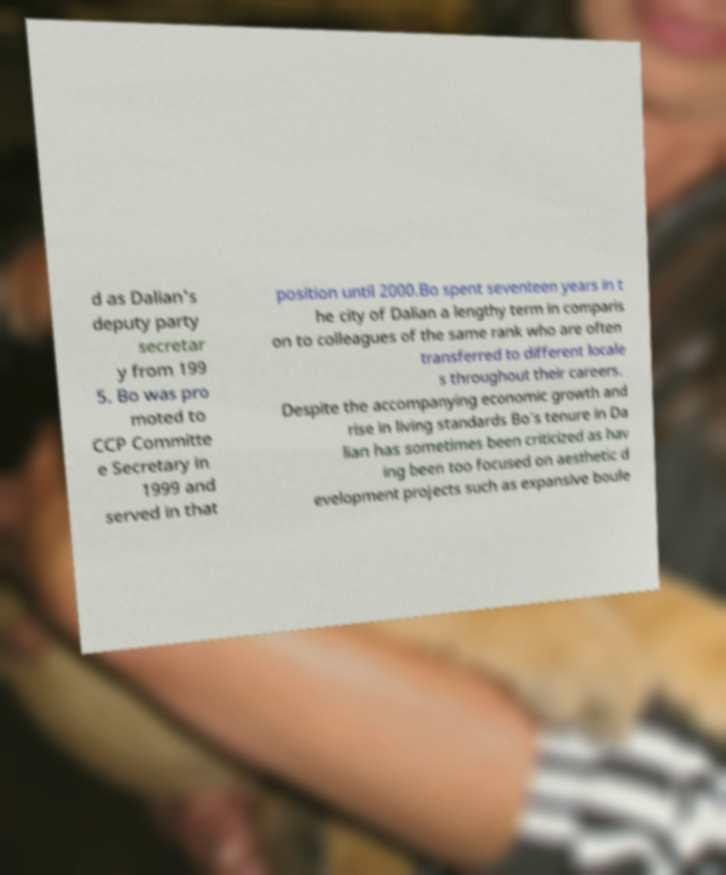Could you assist in decoding the text presented in this image and type it out clearly? d as Dalian's deputy party secretar y from 199 5. Bo was pro moted to CCP Committe e Secretary in 1999 and served in that position until 2000.Bo spent seventeen years in t he city of Dalian a lengthy term in comparis on to colleagues of the same rank who are often transferred to different locale s throughout their careers. Despite the accompanying economic growth and rise in living standards Bo's tenure in Da lian has sometimes been criticized as hav ing been too focused on aesthetic d evelopment projects such as expansive boule 